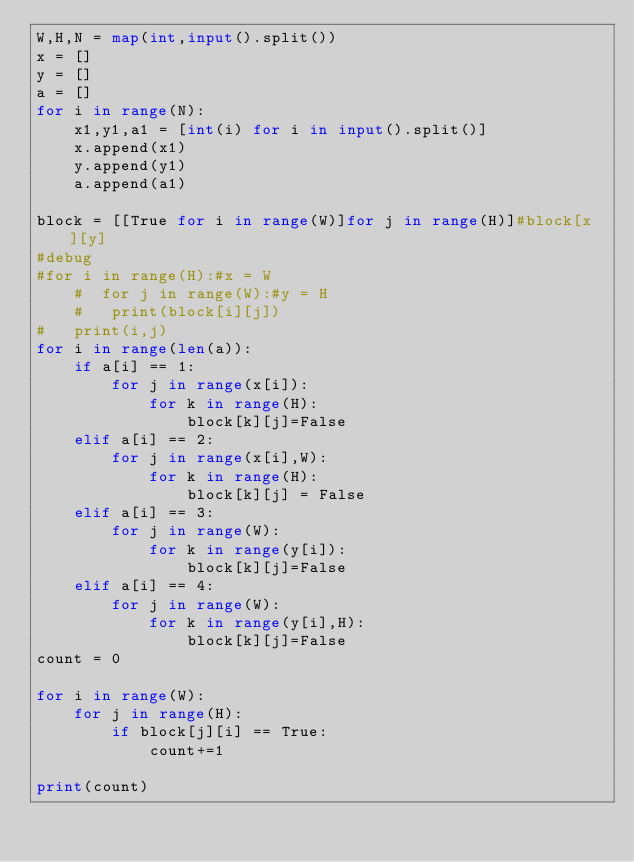<code> <loc_0><loc_0><loc_500><loc_500><_Python_>W,H,N = map(int,input().split())
x = []
y = []
a = []
for i in range(N):
    x1,y1,a1 = [int(i) for i in input().split()]
    x.append(x1)
    y.append(y1)
    a.append(a1)

block = [[True for i in range(W)]for j in range(H)]#block[x][y]
#debug
#for i in range(H):#x = W
    #  for j in range(W):#y = H
    #   print(block[i][j])
#   print(i,j)
for i in range(len(a)):
    if a[i] == 1:
        for j in range(x[i]):
            for k in range(H):
                block[k][j]=False
    elif a[i] == 2:
        for j in range(x[i],W):
            for k in range(H):
                block[k][j] = False
    elif a[i] == 3:
        for j in range(W):
            for k in range(y[i]):
                block[k][j]=False
    elif a[i] == 4:
        for j in range(W):
            for k in range(y[i],H):
                block[k][j]=False
count = 0

for i in range(W):
    for j in range(H):
        if block[j][i] == True:
            count+=1

print(count)

</code> 